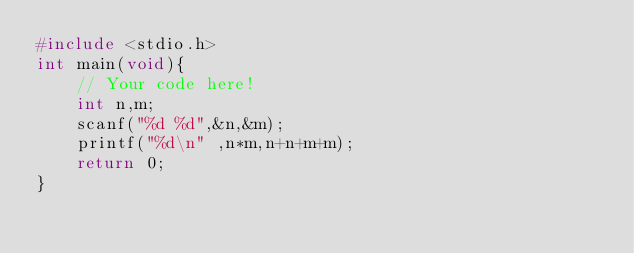Convert code to text. <code><loc_0><loc_0><loc_500><loc_500><_C_>#include <stdio.h>
int main(void){
    // Your code here!
    int n,m;
    scanf("%d %d",&n,&m);
    printf("%d\n" ,n*m,n+n+m+m);
    return 0;
}

</code> 